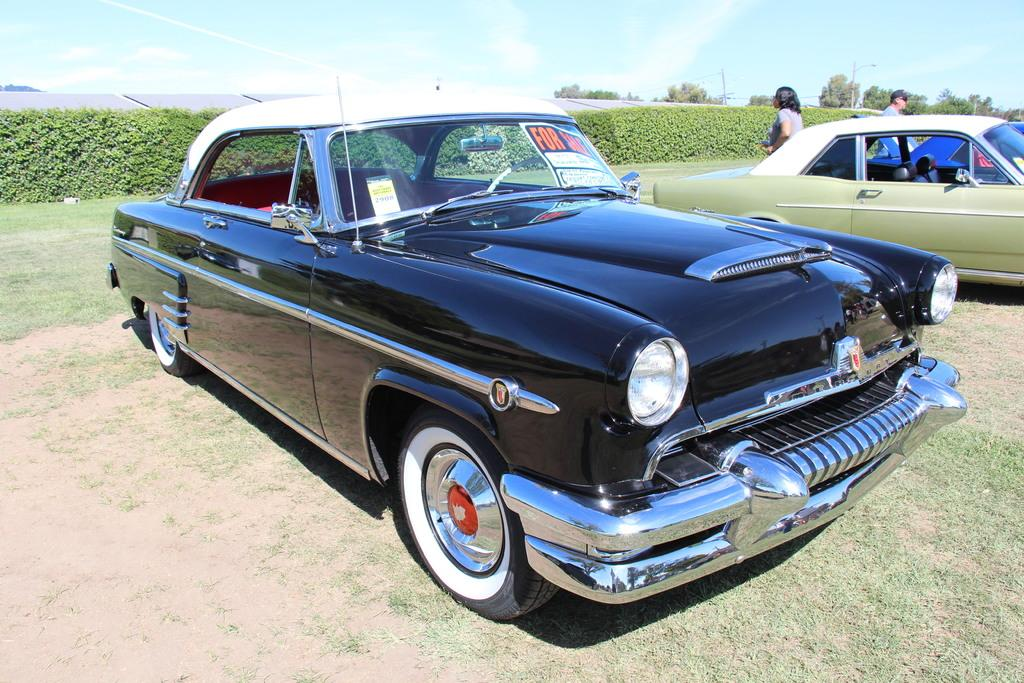What type of vehicles can be seen in the image? There are cars in the image. Who or what else is present in the image? There are people and plants visible in the image. What can be seen in the background of the image? There are trees and the sky visible in the background of the image. What is the texture of the weather in the image? The image does not depict the texture of the weather, as weather is a condition and not a tangible object. 